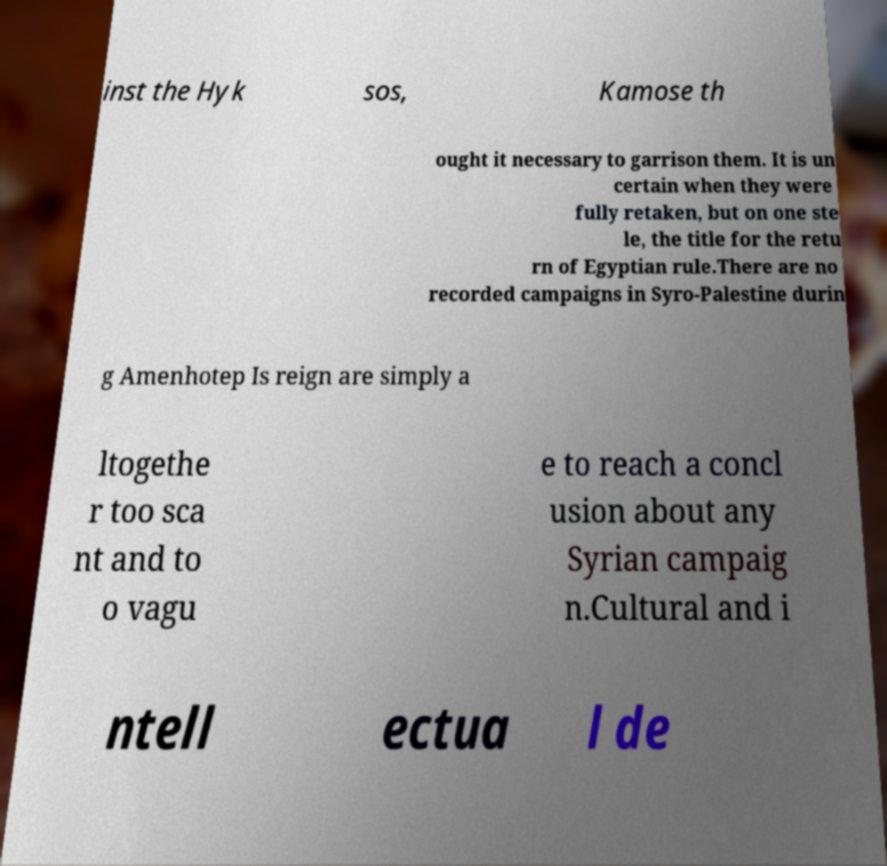Could you assist in decoding the text presented in this image and type it out clearly? inst the Hyk sos, Kamose th ought it necessary to garrison them. It is un certain when they were fully retaken, but on one ste le, the title for the retu rn of Egyptian rule.There are no recorded campaigns in Syro-Palestine durin g Amenhotep Is reign are simply a ltogethe r too sca nt and to o vagu e to reach a concl usion about any Syrian campaig n.Cultural and i ntell ectua l de 